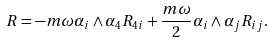Convert formula to latex. <formula><loc_0><loc_0><loc_500><loc_500>R = - m \omega \alpha _ { i } \wedge \alpha _ { 4 } R _ { 4 i } + \frac { m \omega } { 2 } \alpha _ { i } \wedge \alpha _ { j } R _ { i j } .</formula> 